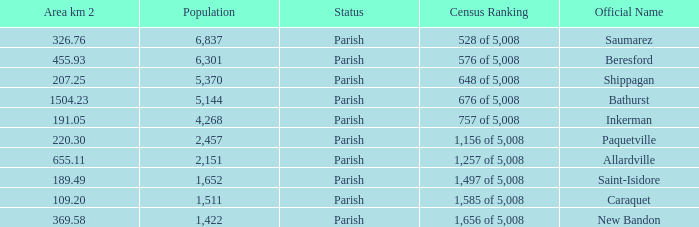What is the Area of the Allardville Parish with a Population smaller than 2,151? None. 